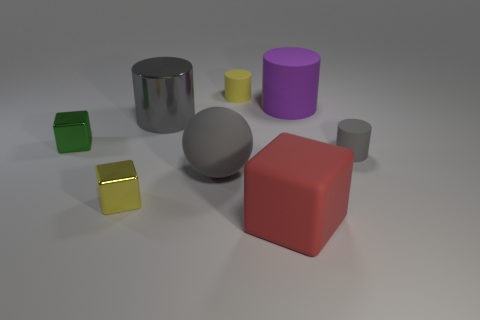What is the shape of the other big thing that is the same color as the big shiny object? The other large object that has the same silvery-grey color as the reflective cylinder is a sphere. Its surface appears matte, in contrast to the shiny metal finish of the cylinder, and it is located just to the left of the central cube when looking at the image. 